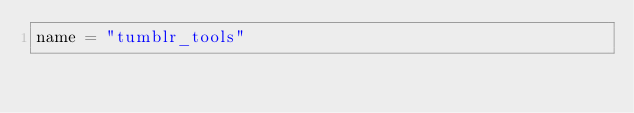Convert code to text. <code><loc_0><loc_0><loc_500><loc_500><_Python_>name = "tumblr_tools"</code> 